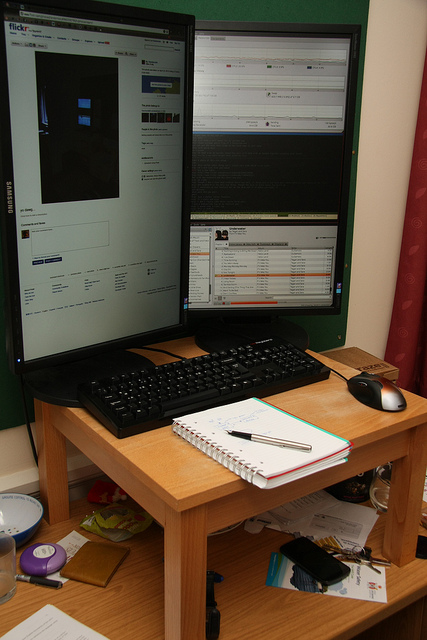Identify the text contained in this image. SAMSUNG 